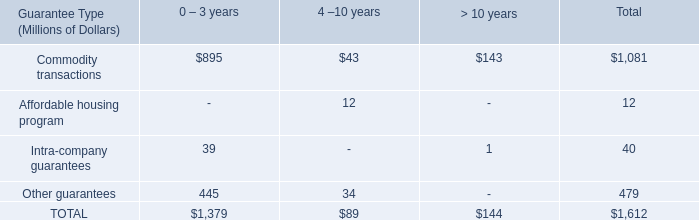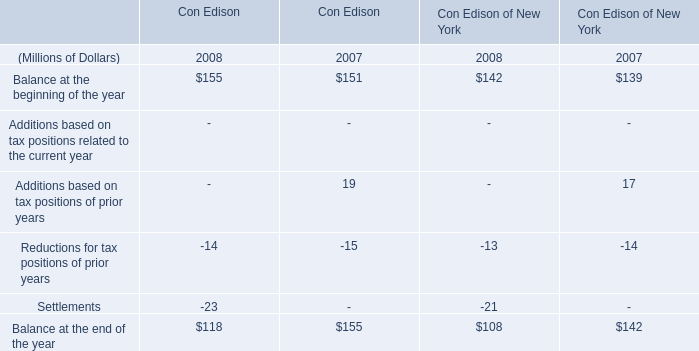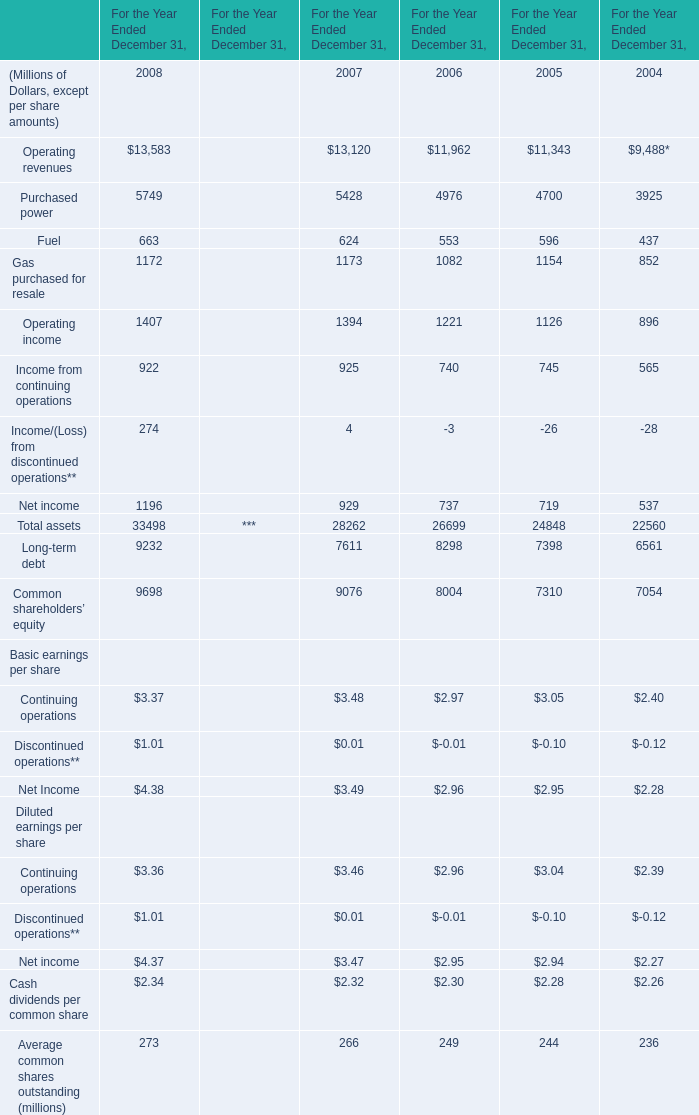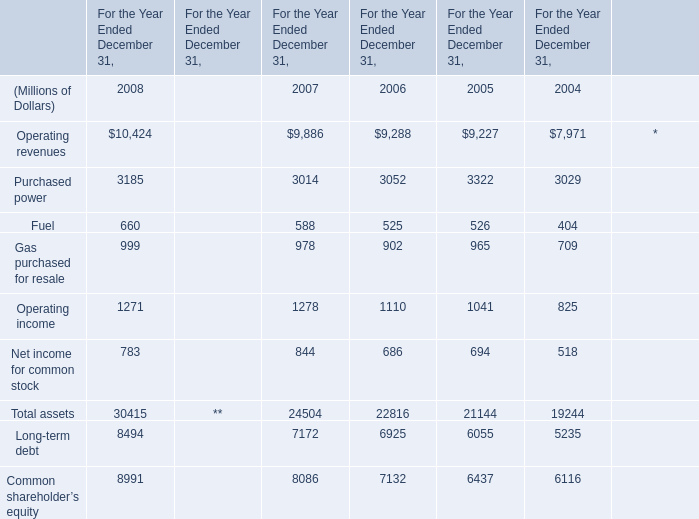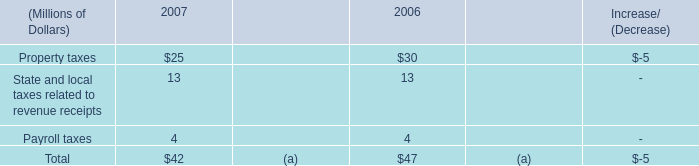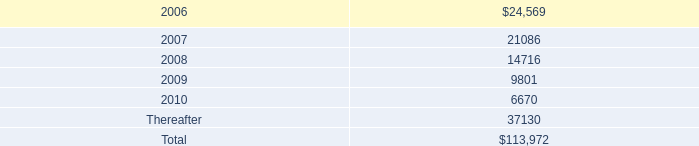what was total lease expense , including base rent on all leases and executory costs , for the years ended december 31 , 2005 and 2004 , in millions? 
Computations: (35.8 + 33.0)
Answer: 68.8. 